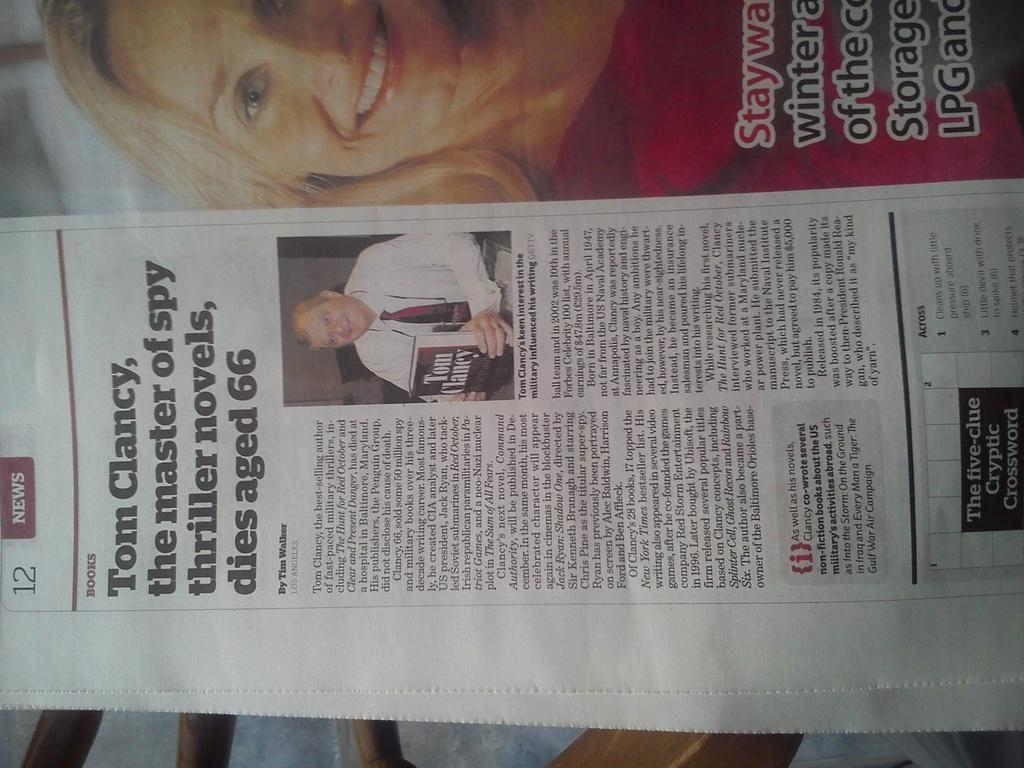What object is present in the image? There is a newspaper in the image. What type of content can be found in the newspaper? The newspaper contains text and pictures. What type of bird is participating in the protest shown in the newspaper? There is no protest or bird mentioned in the image; it only contains a newspaper with text and pictures. 